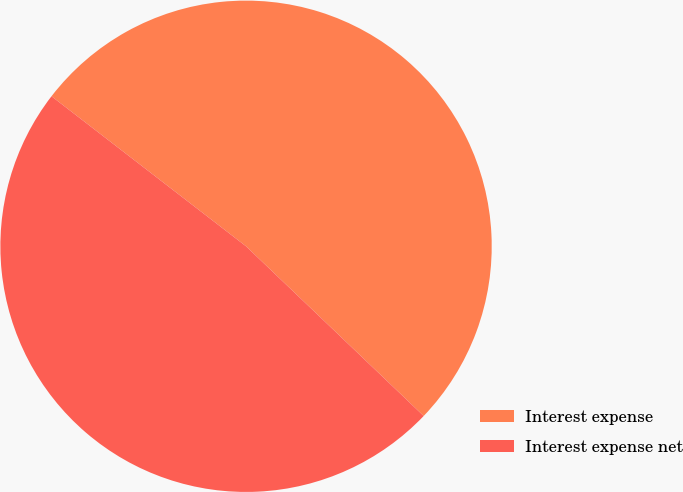Convert chart to OTSL. <chart><loc_0><loc_0><loc_500><loc_500><pie_chart><fcel>Interest expense<fcel>Interest expense net<nl><fcel>51.68%<fcel>48.32%<nl></chart> 